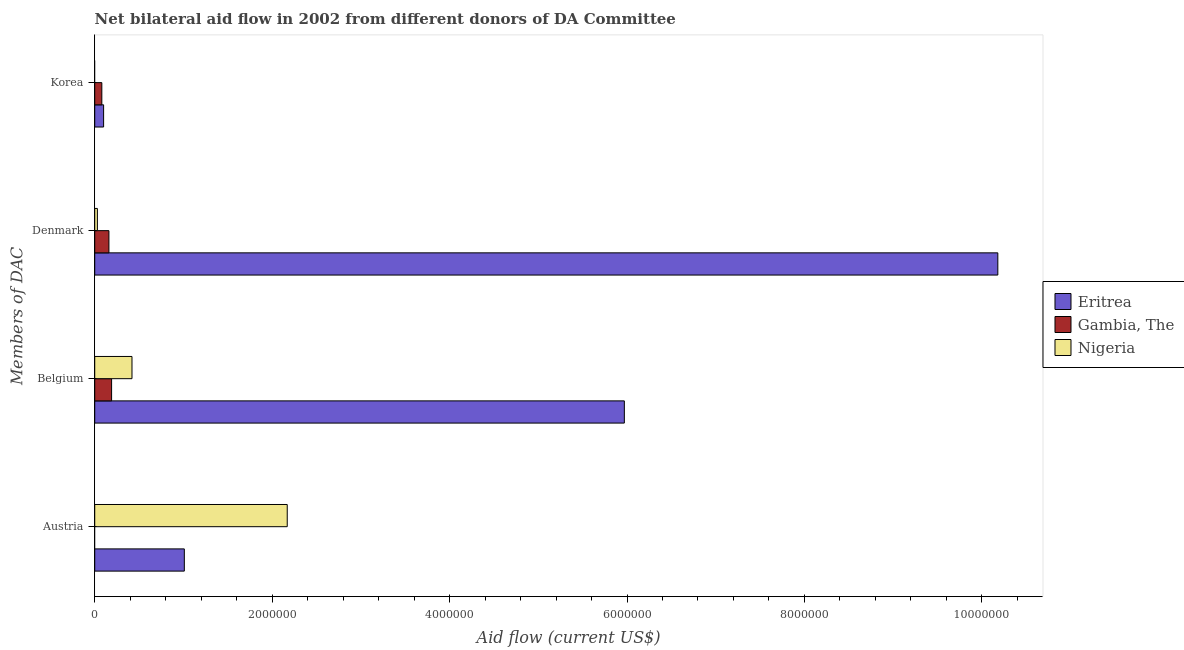How many different coloured bars are there?
Offer a very short reply. 3. How many groups of bars are there?
Your answer should be compact. 4. Are the number of bars per tick equal to the number of legend labels?
Your response must be concise. No. Are the number of bars on each tick of the Y-axis equal?
Provide a short and direct response. No. What is the amount of aid given by belgium in Gambia, The?
Keep it short and to the point. 1.90e+05. Across all countries, what is the maximum amount of aid given by belgium?
Your response must be concise. 5.97e+06. Across all countries, what is the minimum amount of aid given by denmark?
Your response must be concise. 3.00e+04. In which country was the amount of aid given by denmark maximum?
Your response must be concise. Eritrea. What is the total amount of aid given by austria in the graph?
Your answer should be compact. 3.18e+06. What is the difference between the amount of aid given by belgium in Nigeria and that in Eritrea?
Make the answer very short. -5.55e+06. What is the difference between the amount of aid given by austria in Gambia, The and the amount of aid given by denmark in Eritrea?
Offer a terse response. -1.02e+07. What is the difference between the amount of aid given by belgium and amount of aid given by austria in Nigeria?
Ensure brevity in your answer.  -1.75e+06. In how many countries, is the amount of aid given by belgium greater than 2800000 US$?
Ensure brevity in your answer.  1. What is the ratio of the amount of aid given by denmark in Gambia, The to that in Eritrea?
Provide a short and direct response. 0.02. Is the difference between the amount of aid given by belgium in Eritrea and Nigeria greater than the difference between the amount of aid given by austria in Eritrea and Nigeria?
Give a very brief answer. Yes. What is the difference between the highest and the second highest amount of aid given by denmark?
Keep it short and to the point. 1.00e+07. What is the difference between the highest and the lowest amount of aid given by belgium?
Keep it short and to the point. 5.78e+06. In how many countries, is the amount of aid given by belgium greater than the average amount of aid given by belgium taken over all countries?
Make the answer very short. 1. Is it the case that in every country, the sum of the amount of aid given by denmark and amount of aid given by korea is greater than the sum of amount of aid given by austria and amount of aid given by belgium?
Give a very brief answer. No. How many countries are there in the graph?
Your response must be concise. 3. Are the values on the major ticks of X-axis written in scientific E-notation?
Provide a succinct answer. No. Does the graph contain any zero values?
Give a very brief answer. Yes. Where does the legend appear in the graph?
Keep it short and to the point. Center right. How many legend labels are there?
Provide a short and direct response. 3. How are the legend labels stacked?
Your answer should be very brief. Vertical. What is the title of the graph?
Provide a succinct answer. Net bilateral aid flow in 2002 from different donors of DA Committee. What is the label or title of the X-axis?
Offer a terse response. Aid flow (current US$). What is the label or title of the Y-axis?
Make the answer very short. Members of DAC. What is the Aid flow (current US$) of Eritrea in Austria?
Provide a succinct answer. 1.01e+06. What is the Aid flow (current US$) in Nigeria in Austria?
Your response must be concise. 2.17e+06. What is the Aid flow (current US$) in Eritrea in Belgium?
Offer a terse response. 5.97e+06. What is the Aid flow (current US$) of Eritrea in Denmark?
Give a very brief answer. 1.02e+07. What is the Aid flow (current US$) of Gambia, The in Denmark?
Ensure brevity in your answer.  1.60e+05. What is the Aid flow (current US$) in Nigeria in Denmark?
Your answer should be compact. 3.00e+04. What is the Aid flow (current US$) in Eritrea in Korea?
Give a very brief answer. 1.00e+05. What is the Aid flow (current US$) of Gambia, The in Korea?
Give a very brief answer. 8.00e+04. What is the Aid flow (current US$) in Nigeria in Korea?
Give a very brief answer. 0. Across all Members of DAC, what is the maximum Aid flow (current US$) in Eritrea?
Make the answer very short. 1.02e+07. Across all Members of DAC, what is the maximum Aid flow (current US$) of Gambia, The?
Make the answer very short. 1.90e+05. Across all Members of DAC, what is the maximum Aid flow (current US$) in Nigeria?
Your response must be concise. 2.17e+06. Across all Members of DAC, what is the minimum Aid flow (current US$) of Gambia, The?
Offer a very short reply. 0. Across all Members of DAC, what is the minimum Aid flow (current US$) in Nigeria?
Your answer should be compact. 0. What is the total Aid flow (current US$) in Eritrea in the graph?
Offer a very short reply. 1.73e+07. What is the total Aid flow (current US$) of Gambia, The in the graph?
Your answer should be compact. 4.30e+05. What is the total Aid flow (current US$) of Nigeria in the graph?
Ensure brevity in your answer.  2.62e+06. What is the difference between the Aid flow (current US$) in Eritrea in Austria and that in Belgium?
Keep it short and to the point. -4.96e+06. What is the difference between the Aid flow (current US$) in Nigeria in Austria and that in Belgium?
Your response must be concise. 1.75e+06. What is the difference between the Aid flow (current US$) of Eritrea in Austria and that in Denmark?
Ensure brevity in your answer.  -9.17e+06. What is the difference between the Aid flow (current US$) of Nigeria in Austria and that in Denmark?
Offer a very short reply. 2.14e+06. What is the difference between the Aid flow (current US$) in Eritrea in Austria and that in Korea?
Your response must be concise. 9.10e+05. What is the difference between the Aid flow (current US$) in Eritrea in Belgium and that in Denmark?
Provide a short and direct response. -4.21e+06. What is the difference between the Aid flow (current US$) of Eritrea in Belgium and that in Korea?
Keep it short and to the point. 5.87e+06. What is the difference between the Aid flow (current US$) of Eritrea in Denmark and that in Korea?
Offer a very short reply. 1.01e+07. What is the difference between the Aid flow (current US$) of Gambia, The in Denmark and that in Korea?
Your response must be concise. 8.00e+04. What is the difference between the Aid flow (current US$) of Eritrea in Austria and the Aid flow (current US$) of Gambia, The in Belgium?
Keep it short and to the point. 8.20e+05. What is the difference between the Aid flow (current US$) in Eritrea in Austria and the Aid flow (current US$) in Nigeria in Belgium?
Your answer should be very brief. 5.90e+05. What is the difference between the Aid flow (current US$) in Eritrea in Austria and the Aid flow (current US$) in Gambia, The in Denmark?
Give a very brief answer. 8.50e+05. What is the difference between the Aid flow (current US$) in Eritrea in Austria and the Aid flow (current US$) in Nigeria in Denmark?
Offer a terse response. 9.80e+05. What is the difference between the Aid flow (current US$) in Eritrea in Austria and the Aid flow (current US$) in Gambia, The in Korea?
Offer a terse response. 9.30e+05. What is the difference between the Aid flow (current US$) of Eritrea in Belgium and the Aid flow (current US$) of Gambia, The in Denmark?
Provide a succinct answer. 5.81e+06. What is the difference between the Aid flow (current US$) in Eritrea in Belgium and the Aid flow (current US$) in Nigeria in Denmark?
Your answer should be very brief. 5.94e+06. What is the difference between the Aid flow (current US$) of Gambia, The in Belgium and the Aid flow (current US$) of Nigeria in Denmark?
Offer a very short reply. 1.60e+05. What is the difference between the Aid flow (current US$) in Eritrea in Belgium and the Aid flow (current US$) in Gambia, The in Korea?
Make the answer very short. 5.89e+06. What is the difference between the Aid flow (current US$) of Eritrea in Denmark and the Aid flow (current US$) of Gambia, The in Korea?
Offer a very short reply. 1.01e+07. What is the average Aid flow (current US$) of Eritrea per Members of DAC?
Give a very brief answer. 4.32e+06. What is the average Aid flow (current US$) in Gambia, The per Members of DAC?
Ensure brevity in your answer.  1.08e+05. What is the average Aid flow (current US$) in Nigeria per Members of DAC?
Offer a terse response. 6.55e+05. What is the difference between the Aid flow (current US$) of Eritrea and Aid flow (current US$) of Nigeria in Austria?
Keep it short and to the point. -1.16e+06. What is the difference between the Aid flow (current US$) in Eritrea and Aid flow (current US$) in Gambia, The in Belgium?
Provide a short and direct response. 5.78e+06. What is the difference between the Aid flow (current US$) in Eritrea and Aid flow (current US$) in Nigeria in Belgium?
Provide a short and direct response. 5.55e+06. What is the difference between the Aid flow (current US$) of Eritrea and Aid flow (current US$) of Gambia, The in Denmark?
Give a very brief answer. 1.00e+07. What is the difference between the Aid flow (current US$) of Eritrea and Aid flow (current US$) of Nigeria in Denmark?
Offer a very short reply. 1.02e+07. What is the difference between the Aid flow (current US$) of Eritrea and Aid flow (current US$) of Gambia, The in Korea?
Ensure brevity in your answer.  2.00e+04. What is the ratio of the Aid flow (current US$) in Eritrea in Austria to that in Belgium?
Provide a short and direct response. 0.17. What is the ratio of the Aid flow (current US$) of Nigeria in Austria to that in Belgium?
Offer a very short reply. 5.17. What is the ratio of the Aid flow (current US$) in Eritrea in Austria to that in Denmark?
Your answer should be very brief. 0.1. What is the ratio of the Aid flow (current US$) in Nigeria in Austria to that in Denmark?
Your response must be concise. 72.33. What is the ratio of the Aid flow (current US$) of Eritrea in Austria to that in Korea?
Keep it short and to the point. 10.1. What is the ratio of the Aid flow (current US$) of Eritrea in Belgium to that in Denmark?
Keep it short and to the point. 0.59. What is the ratio of the Aid flow (current US$) in Gambia, The in Belgium to that in Denmark?
Your response must be concise. 1.19. What is the ratio of the Aid flow (current US$) of Eritrea in Belgium to that in Korea?
Keep it short and to the point. 59.7. What is the ratio of the Aid flow (current US$) in Gambia, The in Belgium to that in Korea?
Ensure brevity in your answer.  2.38. What is the ratio of the Aid flow (current US$) in Eritrea in Denmark to that in Korea?
Your answer should be very brief. 101.8. What is the difference between the highest and the second highest Aid flow (current US$) of Eritrea?
Your answer should be compact. 4.21e+06. What is the difference between the highest and the second highest Aid flow (current US$) in Nigeria?
Offer a terse response. 1.75e+06. What is the difference between the highest and the lowest Aid flow (current US$) of Eritrea?
Ensure brevity in your answer.  1.01e+07. What is the difference between the highest and the lowest Aid flow (current US$) of Gambia, The?
Ensure brevity in your answer.  1.90e+05. What is the difference between the highest and the lowest Aid flow (current US$) in Nigeria?
Offer a terse response. 2.17e+06. 